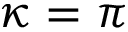<formula> <loc_0><loc_0><loc_500><loc_500>\kappa = \pi</formula> 